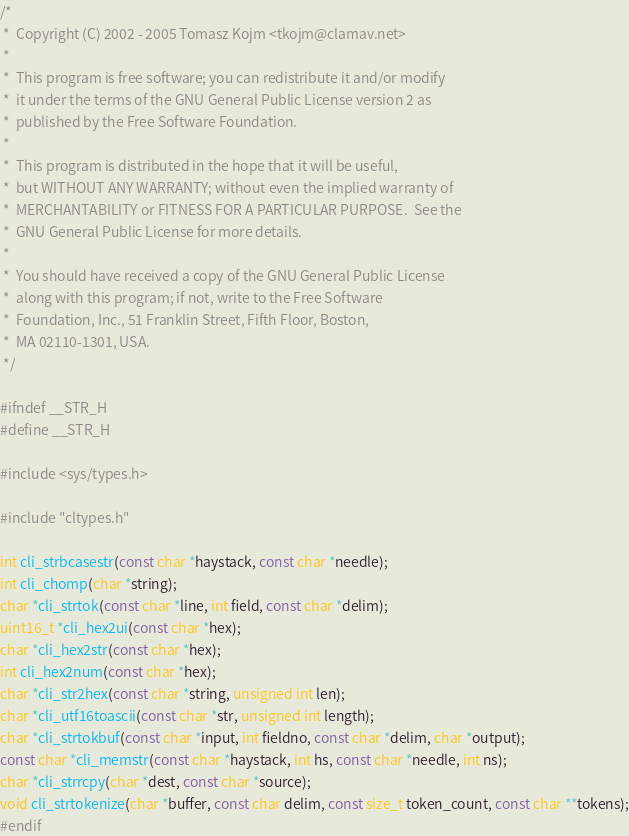<code> <loc_0><loc_0><loc_500><loc_500><_C_>/*
 *  Copyright (C) 2002 - 2005 Tomasz Kojm <tkojm@clamav.net>
 *
 *  This program is free software; you can redistribute it and/or modify
 *  it under the terms of the GNU General Public License version 2 as
 *  published by the Free Software Foundation.
 *
 *  This program is distributed in the hope that it will be useful,
 *  but WITHOUT ANY WARRANTY; without even the implied warranty of
 *  MERCHANTABILITY or FITNESS FOR A PARTICULAR PURPOSE.  See the
 *  GNU General Public License for more details.
 *
 *  You should have received a copy of the GNU General Public License
 *  along with this program; if not, write to the Free Software
 *  Foundation, Inc., 51 Franklin Street, Fifth Floor, Boston,
 *  MA 02110-1301, USA.
 */

#ifndef __STR_H
#define __STR_H

#include <sys/types.h>

#include "cltypes.h"

int cli_strbcasestr(const char *haystack, const char *needle);
int cli_chomp(char *string);
char *cli_strtok(const char *line, int field, const char *delim);
uint16_t *cli_hex2ui(const char *hex);
char *cli_hex2str(const char *hex);
int cli_hex2num(const char *hex);
char *cli_str2hex(const char *string, unsigned int len);
char *cli_utf16toascii(const char *str, unsigned int length);
char *cli_strtokbuf(const char *input, int fieldno, const char *delim, char *output);
const char *cli_memstr(const char *haystack, int hs, const char *needle, int ns);
char *cli_strrcpy(char *dest, const char *source);
void cli_strtokenize(char *buffer, const char delim, const size_t token_count, const char **tokens);
#endif
</code> 